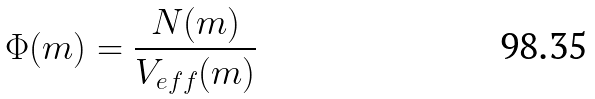<formula> <loc_0><loc_0><loc_500><loc_500>\Phi ( m ) = \frac { N ( m ) } { V _ { e f f } ( m ) }</formula> 